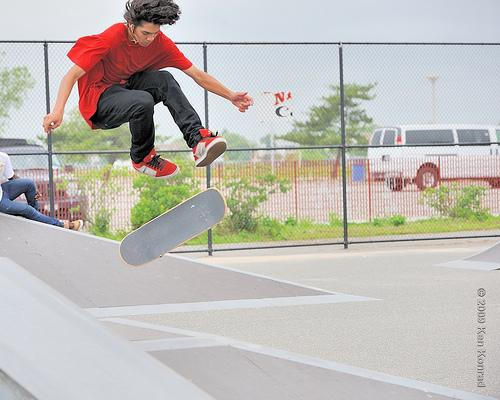Express the scene in the image, focusing on the skateboarder's stance and appearance. A young male skateboarder with long hair, red shirt and tennis shoes in mid-air, flipping his black skateboard during a trick. Describe the young man's hairstyle and what's happening with the skateboard in the photo. The boy with dark, long hair is performing a mid-air trick with his black skateboard flipped sideways. Mention the location where the image was taken and the main subject doing the action. At a skate park, a young man with long hair performs a skateboarding trick in mid-air while looking down. Narrate the position of the boy, skateboard, and other noticeable objects in the image. A boy is in mid-air above a skating ramp, with his flipped black skateboard, near a chain-link fence and a white van behind it. Describe the clothing and the skateboard of the person in the image. The skateboarder has a red shirt, long pants, red and black lettering, and red, black, and white tennis shoes, with a black skateboard. Point out the prominent objects and their relative positions in the image. A boy and his black skateboard are mid-air above a skateboarding ramp, with a chain-link fence and a parked van in the background. Mention the key elements in the image, including the fencing and location. A skateboarder is mid-air at a skate park, with ramps, a glossy black chain fence, greenery, and a parked van in the background. Provide a brief overview of the scene captured in the image. A skateboarder in mid-air performs a trick at a skate park with ramps, fence, and a parked van in the background. Describe the environment around the skateboarder in the image. The skateboarder is in mid-air at a skate park with ramps, green trees by a fence, and a parked white van in the background. Mention the key objects and their colors in the image. The image includes a boy with dark hair wearing a red shirt, long pants, red and white shoes, and a black skateboard in mid-air. 